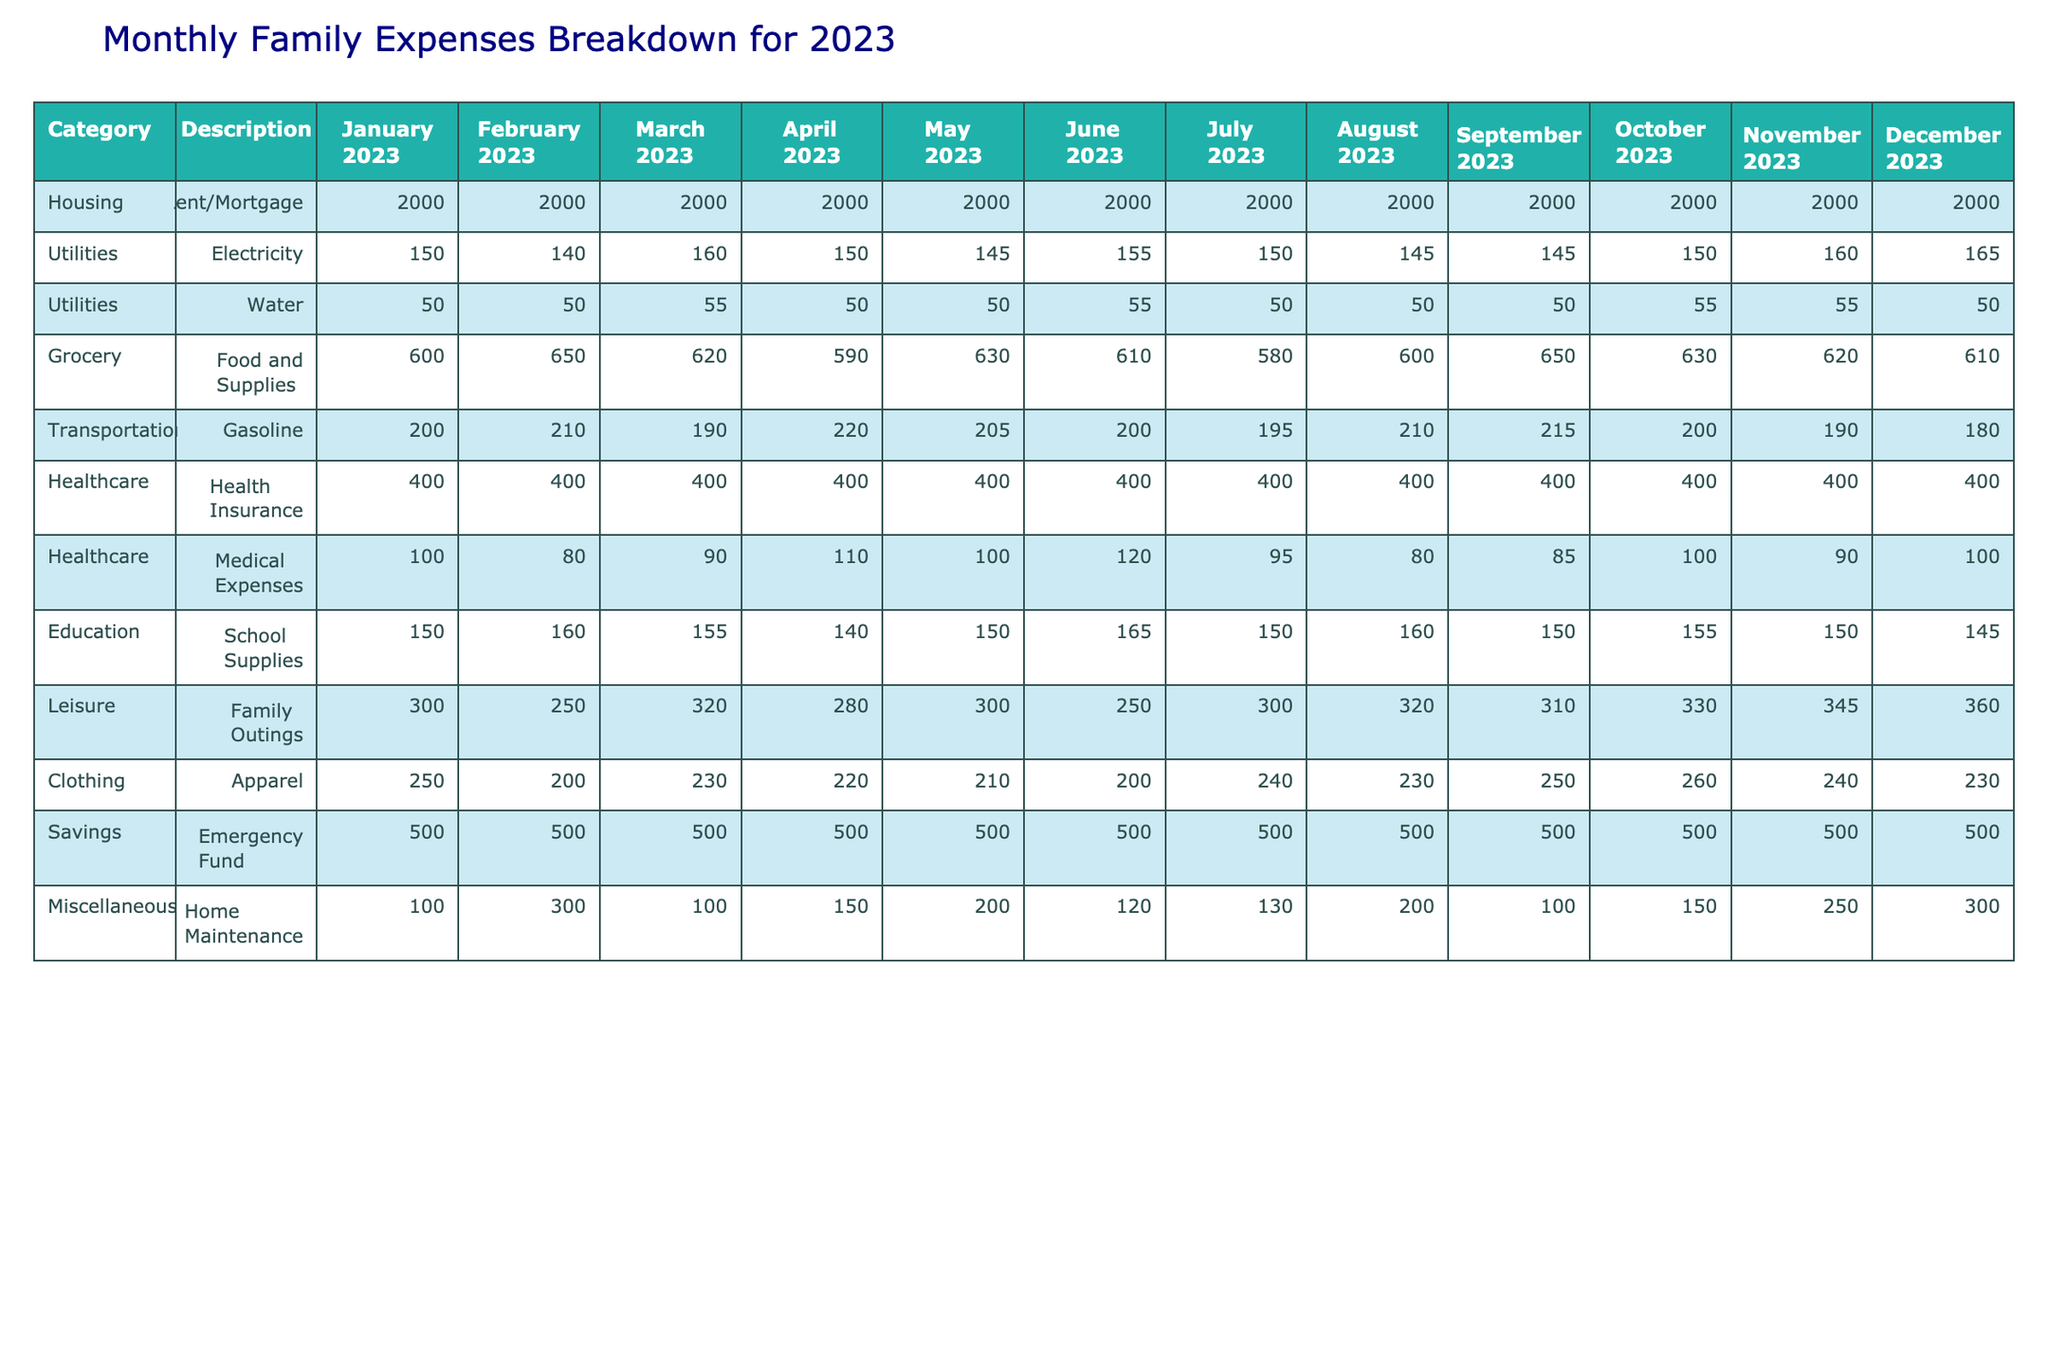What is the total expense for Housing in 2023? To find the total expense for Housing, we sum the monthly expenses listed for Rent/Mortgage: 2000 + 2000 + 2000 + 2000 + 2000 + 2000 + 2000 + 2000 + 2000 + 2000 + 2000 + 2000 = 24000
Answer: 24000 Which month had the highest expense in Leisure for Family Outings? Looking across the Leisure category for Family Outings, we see the monthly values are 300, 250, 320, 280, 300, 250, 300, 320, 310, 330, 345, 360. The highest value is 360 in December.
Answer: December What is the average monthly expense for Utilities? The monthly amounts for Utilities (Electricity + Water) are: (150+140+160+150+145+155+150+145+145+150+160+165) + (50+50+55+50+50+55+50+50+50+55+55+50) = 1735 for Electricity and 600 for Water. The total for Utilities is 2335. With 12 months, the average is 2335/12 = 194.58, rounded to 195.
Answer: 195 Did the Grocery expenses exceed 600 in more than half of the months? The Grocery expenses are 600, 650, 620, 590, 630, 610, 580, 600, 650, 630, 620, 610. The values greater than 600 are 650, 620, 630, 610, 630, and 620, totaling 6 months, which is more than half of 12.
Answer: Yes What was the change in Clothing expenses from January to December? The expense in January is 250, and in December, it is 230. The change is calculated as 230 - 250 = -20, indicating a decrease.
Answer: -20 Which category had the least expense in March? Reviewing the expenses for March, we find the least expense in the Medical Expenses category at 90, compared to other categories with higher amounts.
Answer: Medical Expenses What is the total expense for the Miscellaneous category for 2023? The expenses for the Miscellaneous category (Home Maintenance) are: 100 + 300 + 100 + 150 + 200 + 120 + 130 + 200 + 100 + 150 + 250 + 300 = 2100.
Answer: 2100 In which month did the family spend the least on Transportation? The monthly expenses for Transportation (Gasoline) are: 200, 210, 190, 220, 205, 200, 195, 210, 215, 200, 190, 180. The least expense is in December at 180.
Answer: December Calculate the total Healthcare expenses for the first half of 2023. The Healthcare expenses are Health Insurance (400 each month) and Medical Expenses (100, 80, 90, 110, 100, 120). For the first half, Health Insurance sums to 2400, and Medical Expenses total 600. So, the total is 2400 + 600 = 3000.
Answer: 3000 Was the amount spent on leisure activities higher than that on Clothing in any month? Comparing Leisure and Clothing categories month by month, we find that in December, Leisure at 360 exceeds Clothing at 230. So, yes, Leisure spending was higher in December.
Answer: Yes 